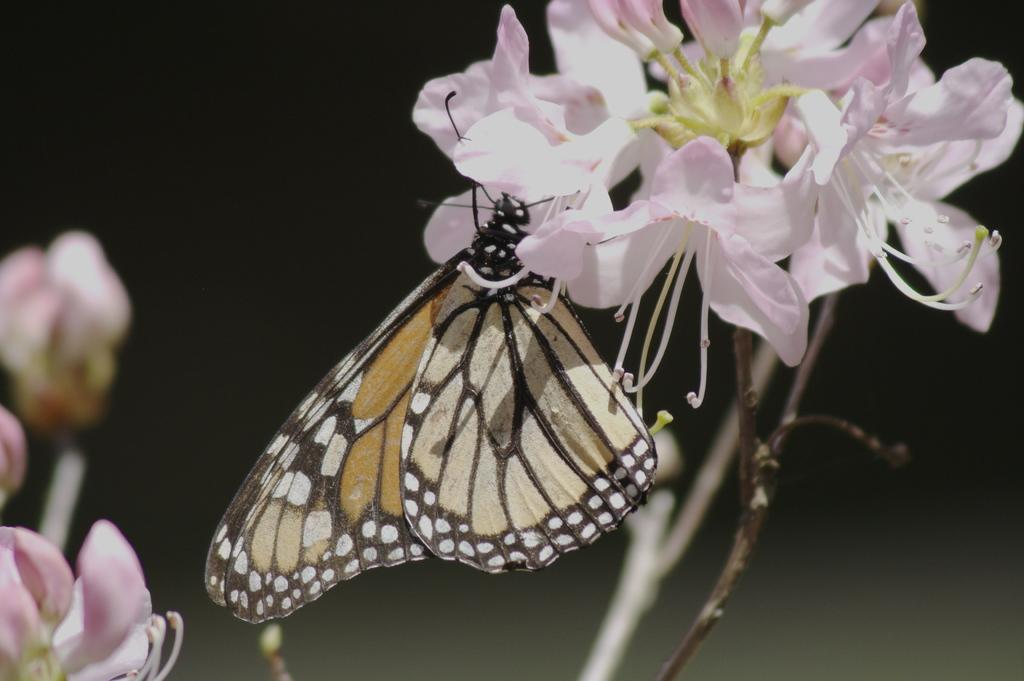What is the main subject of the image? There is a butterfly in the image. Where is the butterfly located? The butterfly is on a flower. What color are the flowers in the image? There are pink flowers in the image. How would you describe the background of the image? The background of the image is dark and blurred. What decision does the butterfly make while on the flower in the image? The butterfly does not make any decisions in the image; it is simply resting on the flower. What type of gold object can be seen in the image? There is no gold object present in the image. 